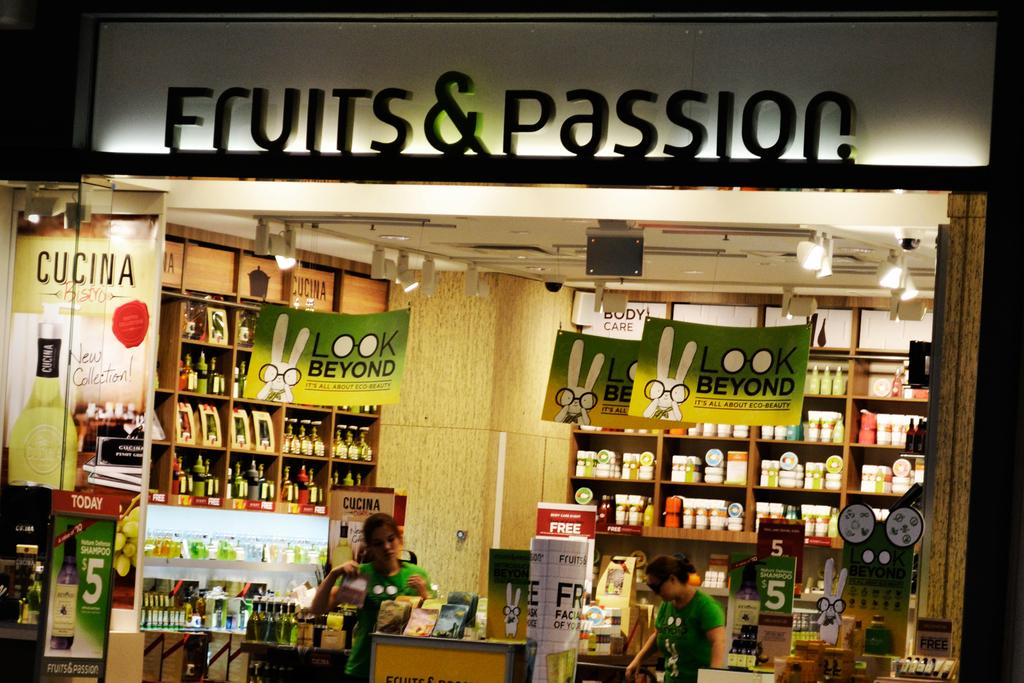Provide a one-sentence caption for the provided image. Two women standing inside a very well organized store called Fruits & Passion. 